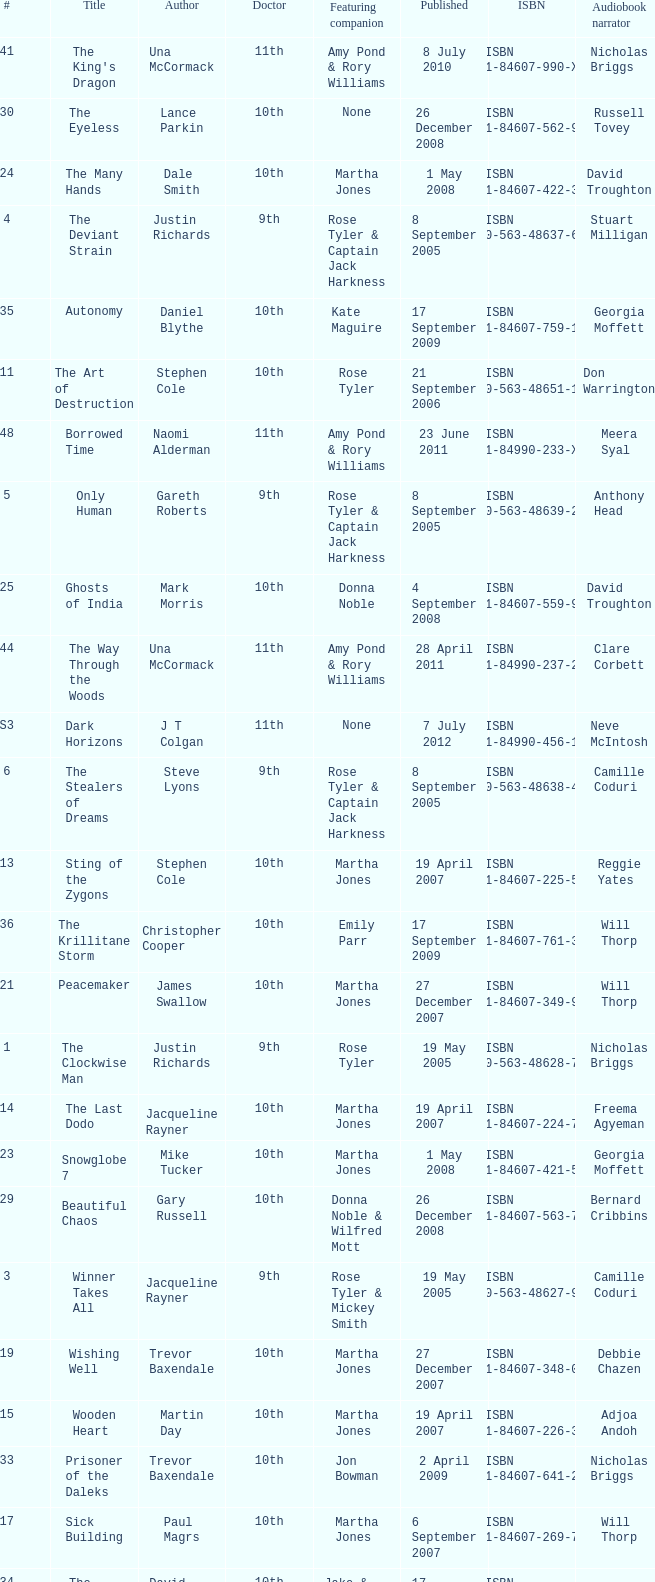What is the title of book number 7? The Stone Rose. 